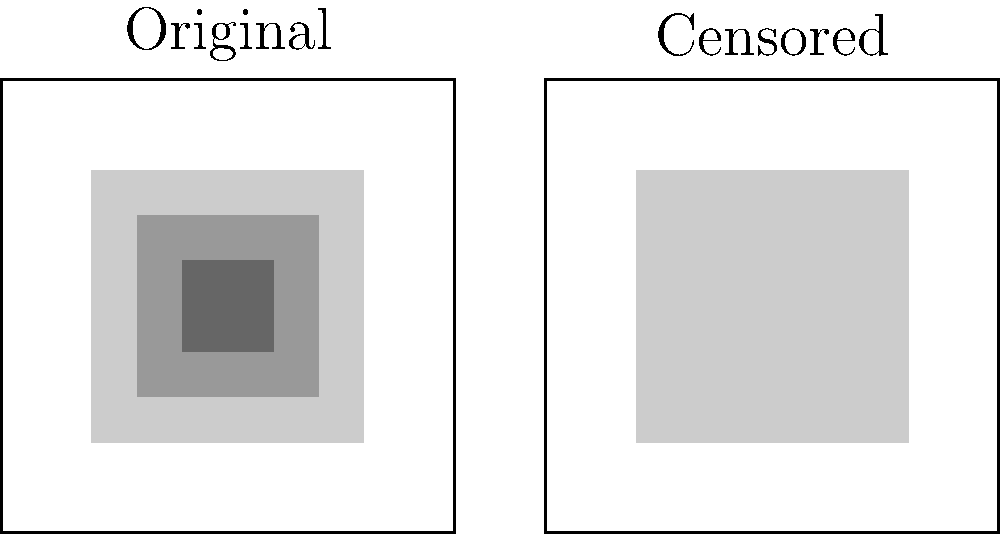In the context of media censorship, analyze the visual representation of the original and censored images. What percentage of the original image's area has been obscured in the censored version? To determine the percentage of the original image that has been obscured in the censored version, we need to follow these steps:

1. Observe that the original image is represented by a square, which we can assume has dimensions of 100x100 units.

2. In the censored version, we see a single large gray rectangle covering a portion of the image.

3. This gray rectangle appears to cover approximately 60% of the width and 60% of the height of the image.

4. To calculate the area of the censored portion:
   Area of censored portion = 60 * 60 = 3600 square units

5. The total area of the original image:
   Total area = 100 * 100 = 10000 square units

6. To calculate the percentage of the image that has been censored:
   Percentage censored = (Area of censored portion / Total area) * 100
   = (3600 / 10000) * 100
   = 0.36 * 100
   = 36%

Therefore, approximately 36% of the original image's area has been obscured in the censored version.
Answer: 36% 